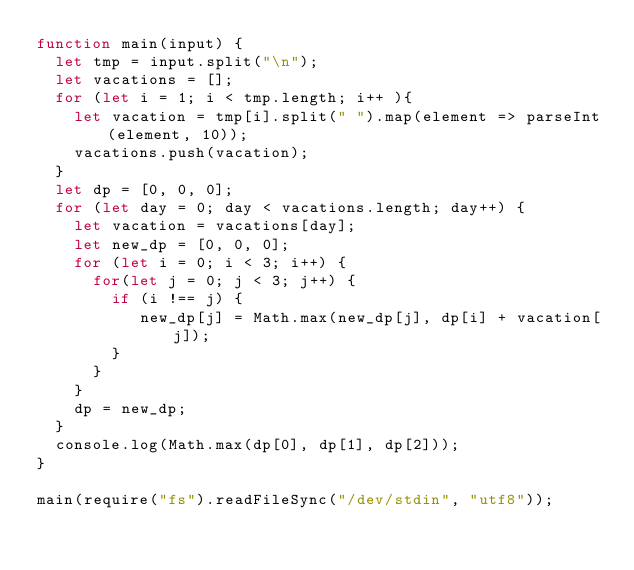<code> <loc_0><loc_0><loc_500><loc_500><_JavaScript_>function main(input) {
  let tmp = input.split("\n");
  let vacations = [];
  for (let i = 1; i < tmp.length; i++ ){
    let vacation = tmp[i].split(" ").map(element => parseInt(element, 10));
    vacations.push(vacation);
  }
  let dp = [0, 0, 0];
  for (let day = 0; day < vacations.length; day++) {
    let vacation = vacations[day];
    let new_dp = [0, 0, 0];
    for (let i = 0; i < 3; i++) {
      for(let j = 0; j < 3; j++) {
        if (i !== j) {
           new_dp[j] = Math.max(new_dp[j], dp[i] + vacation[j]);
        }
      }
    }
    dp = new_dp;
  }
  console.log(Math.max(dp[0], dp[1], dp[2]));
}

main(require("fs").readFileSync("/dev/stdin", "utf8"));</code> 